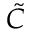Convert formula to latex. <formula><loc_0><loc_0><loc_500><loc_500>\tilde { C }</formula> 